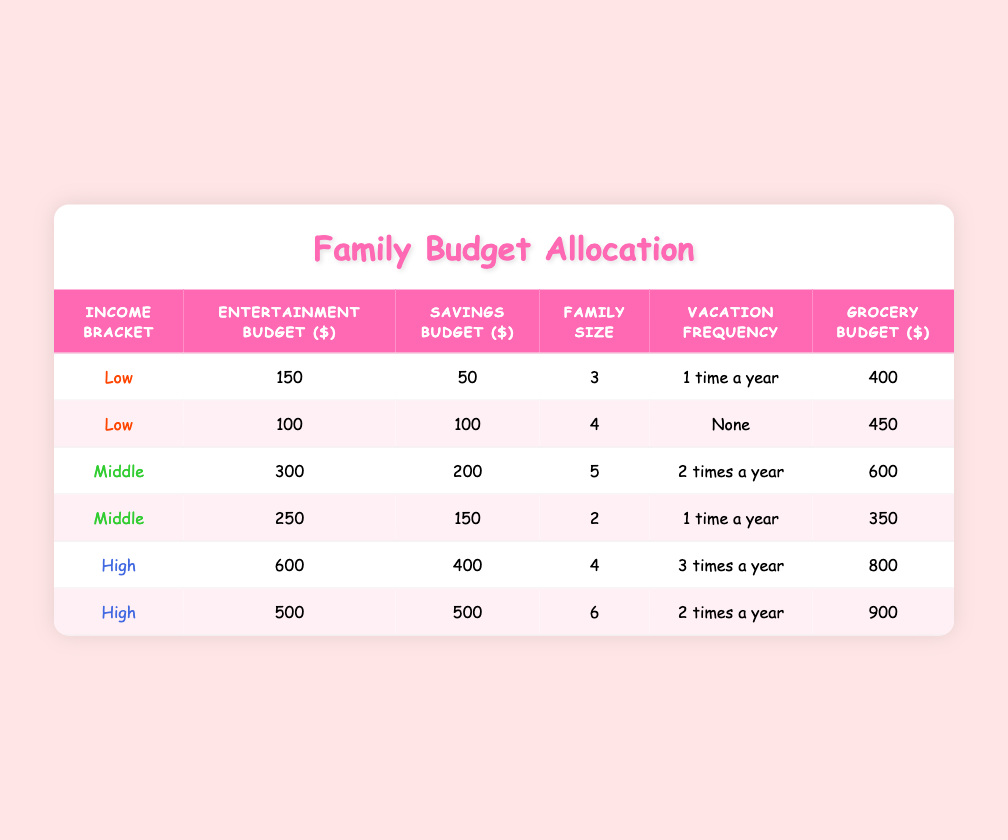What is the entertainment budget for a family in the low-income bracket? The table contains two entries for the low-income bracket. The entertainment budgets are 150 and 100.
Answer: 150 and 100 How many vacation times does the high-income family take? There are two entries for high-income families. One vacation frequency is 3 times a year, and the other is 2 times a year.
Answer: 3 and 2 What is the average savings budget for middle-income families? There are two middle-income entries with savings budgets of 200 and 150. The average is (200 + 150) / 2 = 175.
Answer: 175 Is the grocery budget for any low-income family above 450? For low-income families, the grocery budgets are 400 and 450. Both are not above 450, making the statement false.
Answer: No Which income bracket has the highest total entertainment budget? The total entertainment budgets are 150 + 100 = 250 (low), 300 + 250 = 550 (middle), and 600 + 500 = 1100 (high). The highest total is 1100 for the high-income bracket.
Answer: High What is the difference in entertainment budgets between the middle and high-income families? The middle-income families have entertainment budgets totaling 300 + 250 = 550, while high-income families have 600 + 500 = 1100. The difference is 1100 - 550 = 550.
Answer: 550 How many families take vacations, according to the table? The table shows vacation frequencies: "1 time a year" for 2 families, "2 times a year" for 2 families, and "None" for 1 family, with one family vacationing 3 times a year. Thus, 5 out of 6 families take vacations.
Answer: 5 families What is the total family size for families in the high-income bracket? The high-income families have sizes of 4 and 6. Adding these gives a total of 4 + 6 = 10.
Answer: 10 Do all families save more than they spend on entertainment? Low-income families save 50 and 100 against entertainment budgets of 150 and 100; middle-income families save 200 and 150 against budgets of 300 and 250; high-income families save 400 and 500 against budgets of 600 and 500. Therefore, not all save more than they spend, particularly the first low-income family, which spends more on entertainment than it saves.
Answer: No 